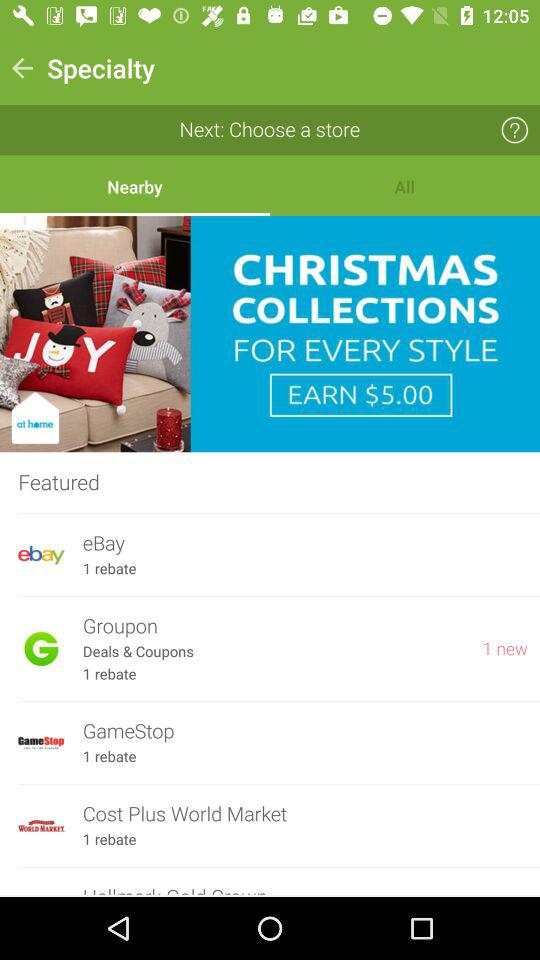What is the total number of rebates in the Cost Plus World Market? The total number of rebates is 1. 